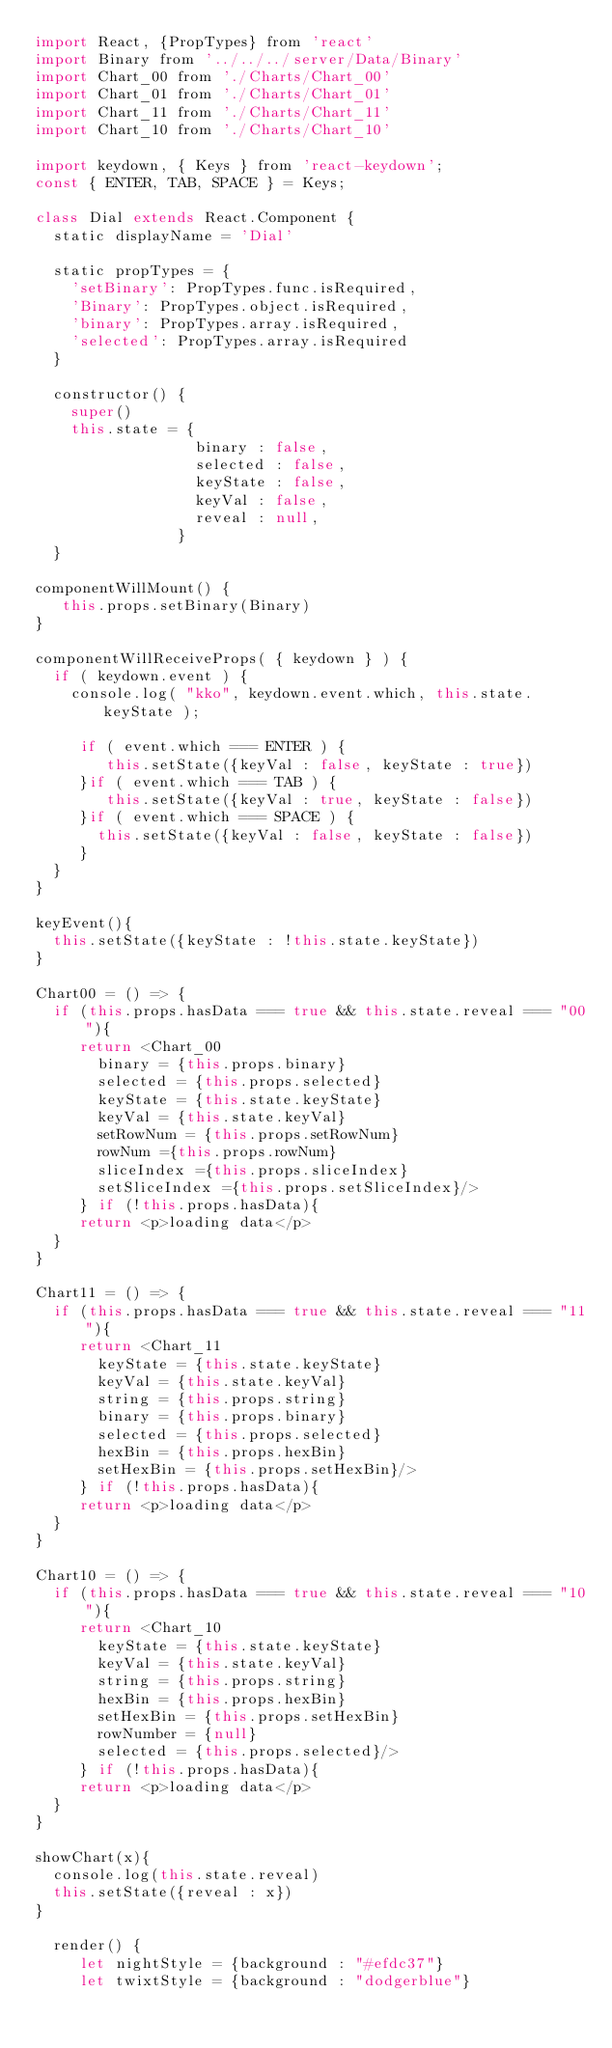Convert code to text. <code><loc_0><loc_0><loc_500><loc_500><_JavaScript_>import React, {PropTypes} from 'react'
import Binary from '../../../server/Data/Binary'
import Chart_00 from './Charts/Chart_00'
import Chart_01 from './Charts/Chart_01'
import Chart_11 from './Charts/Chart_11'
import Chart_10 from './Charts/Chart_10'

import keydown, { Keys } from 'react-keydown';
const { ENTER, TAB, SPACE } = Keys;

class Dial extends React.Component {
  static displayName = 'Dial'

  static propTypes = {
    'setBinary': PropTypes.func.isRequired,
    'Binary': PropTypes.object.isRequired,
    'binary': PropTypes.array.isRequired,
    'selected': PropTypes.array.isRequired
  }

  constructor() {
    super()
    this.state = {
                  binary : false, 
                  selected : false, 
                  keyState : false,
                  keyVal : false,
                  reveal : null,
                }
  }

componentWillMount() {
   this.props.setBinary(Binary)
}

componentWillReceiveProps( { keydown } ) {
  if ( keydown.event ) {
    console.log( "kko", keydown.event.which, this.state.keyState );
    
     if ( event.which === ENTER ) {
        this.setState({keyVal : false, keyState : true})
     }if ( event.which === TAB ) {
        this.setState({keyVal : true, keyState : false})
     }if ( event.which === SPACE ) {
       this.setState({keyVal : false, keyState : false})
     }
  }
}

keyEvent(){   
  this.setState({keyState : !this.state.keyState})
}

Chart00 = () => {
  if (this.props.hasData === true && this.state.reveal === "00"){
     return <Chart_00
       binary = {this.props.binary}
       selected = {this.props.selected}
       keyState = {this.state.keyState}
       keyVal = {this.state.keyVal}
       setRowNum = {this.props.setRowNum}
       rowNum ={this.props.rowNum}
       sliceIndex ={this.props.sliceIndex}
       setSliceIndex ={this.props.setSliceIndex}/>
     } if (!this.props.hasData){
     return <p>loading data</p>
  }
}

Chart11 = () => {
  if (this.props.hasData === true && this.state.reveal === "11"){
     return <Chart_11
       keyState = {this.state.keyState}
       keyVal = {this.state.keyVal}
       string = {this.props.string}
       binary = {this.props.binary}
       selected = {this.props.selected}
       hexBin = {this.props.hexBin}
       setHexBin = {this.props.setHexBin}/>
     } if (!this.props.hasData){
     return <p>loading data</p>
  }
}

Chart10 = () => {
  if (this.props.hasData === true && this.state.reveal === "10"){
     return <Chart_10
       keyState = {this.state.keyState}
       keyVal = {this.state.keyVal}
       string = {this.props.string}
       hexBin = {this.props.hexBin}
       setHexBin = {this.props.setHexBin}
       rowNumber = {null}
       selected = {this.props.selected}/>
     } if (!this.props.hasData){
     return <p>loading data</p>
  }
}

showChart(x){
  console.log(this.state.reveal)
  this.setState({reveal : x})
}

  render() {
     let nightStyle = {background : "#efdc37"}
     let twixtStyle = {background : "dodgerblue"}</code> 